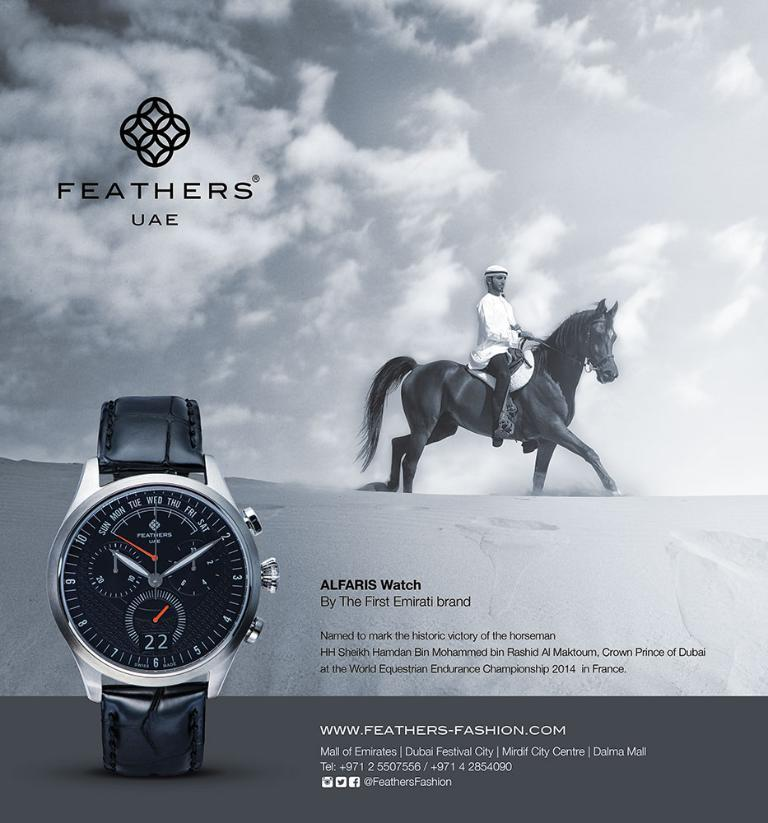<image>
Offer a succinct explanation of the picture presented. A black and white advertisement for an Alfaris watch 